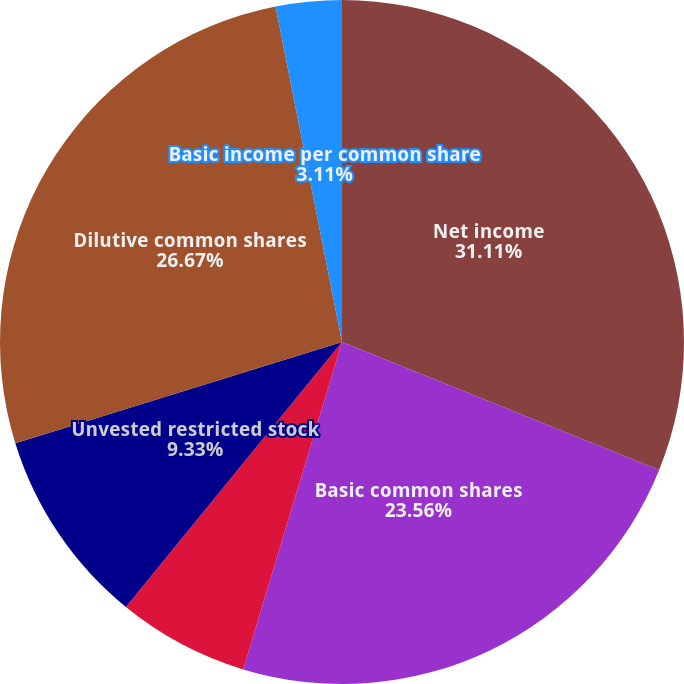<chart> <loc_0><loc_0><loc_500><loc_500><pie_chart><fcel>Net income<fcel>Basic common shares<fcel>Stock options<fcel>Unvested restricted stock<fcel>Dilutive common shares<fcel>Basic income per common share<fcel>Diluted income per common<nl><fcel>31.1%<fcel>23.56%<fcel>6.22%<fcel>9.33%<fcel>26.67%<fcel>3.11%<fcel>0.0%<nl></chart> 